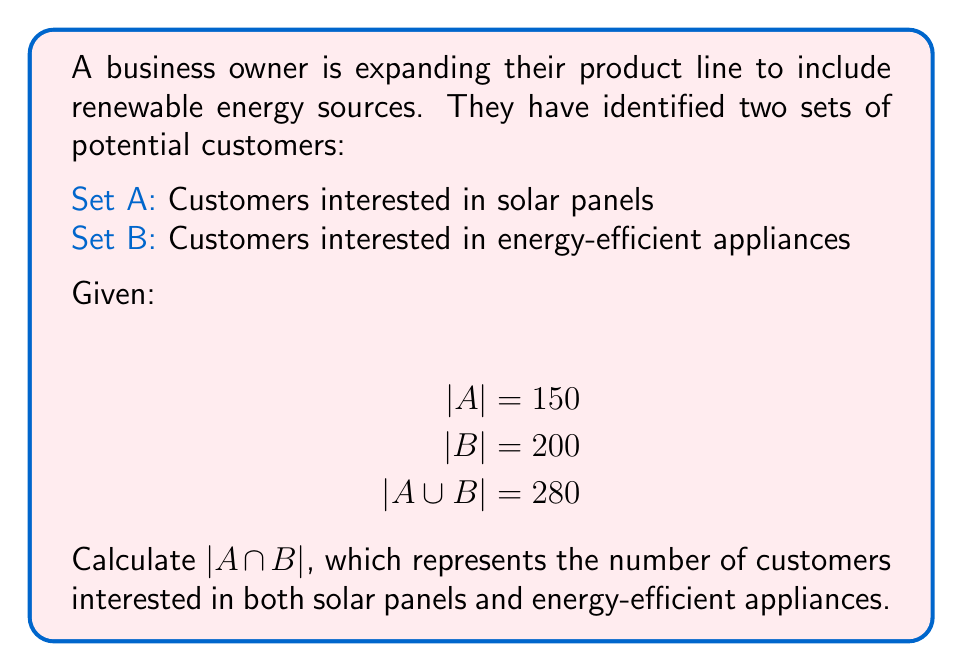Could you help me with this problem? To solve this problem, we'll use the formula for the number of elements in the union of two sets:

$|A \cup B| = |A| + |B| - |A \cap B|$

We know:
$|A \cup B| = 280$
$|A| = 150$
$|B| = 200$

Let's substitute these values into the formula:

$280 = 150 + 200 - |A \cap B|$

Now, we can solve for $|A \cap B|$:

$280 = 350 - |A \cap B|$
$|A \cap B| = 350 - 280$
$|A \cap B| = 70$

This means that 70 customers are interested in both solar panels and energy-efficient appliances.

[asy]
unitsize(1cm);

draw(circle((0,0),3), linewidth(0.7));
draw(circle((2,0),3), linewidth(0.7));

label("A", (-2,0));
label("B", (4,0));
label("150", (-1.5,2));
label("200", (3.5,2));
label("70", (1,0));

draw((1,0)--(1,2), dashed);
label("280", (1,2.5));
[/asy]

This Venn diagram illustrates the relationship between sets A and B, showing the intersection of 70 customers.
Answer: $|A \cap B| = 70$ 